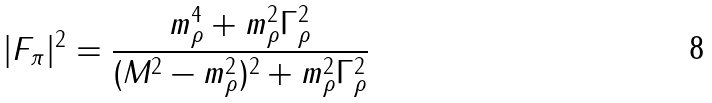Convert formula to latex. <formula><loc_0><loc_0><loc_500><loc_500>| F _ { \pi } | ^ { 2 } = \frac { m _ { \rho } ^ { 4 } + m _ { \rho } ^ { 2 } \Gamma _ { \rho } ^ { 2 } } { ( M ^ { 2 } - m _ { \rho } ^ { 2 } ) ^ { 2 } + m _ { \rho } ^ { 2 } \Gamma _ { \rho } ^ { 2 } }</formula> 